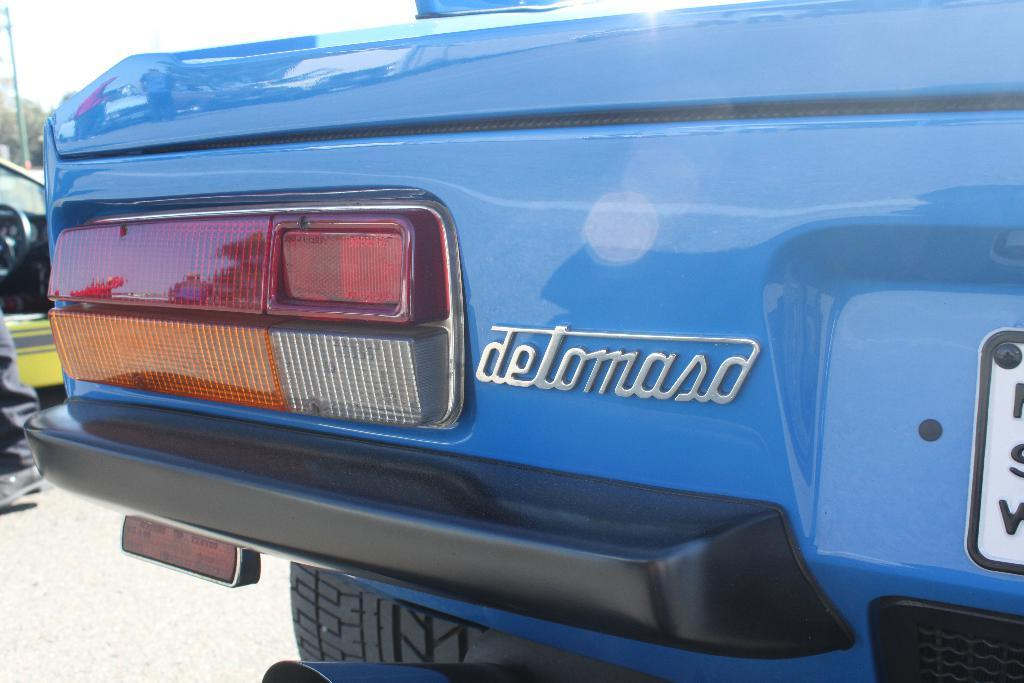What types of objects are present in the image? There are vehicles in the image. Can you describe any other object in the image besides the vehicles? Yes, there is a pole in the image. What is the design of the skate on the tail of the vehicle in the image? There is no skate or tail present on the vehicles in the image. 